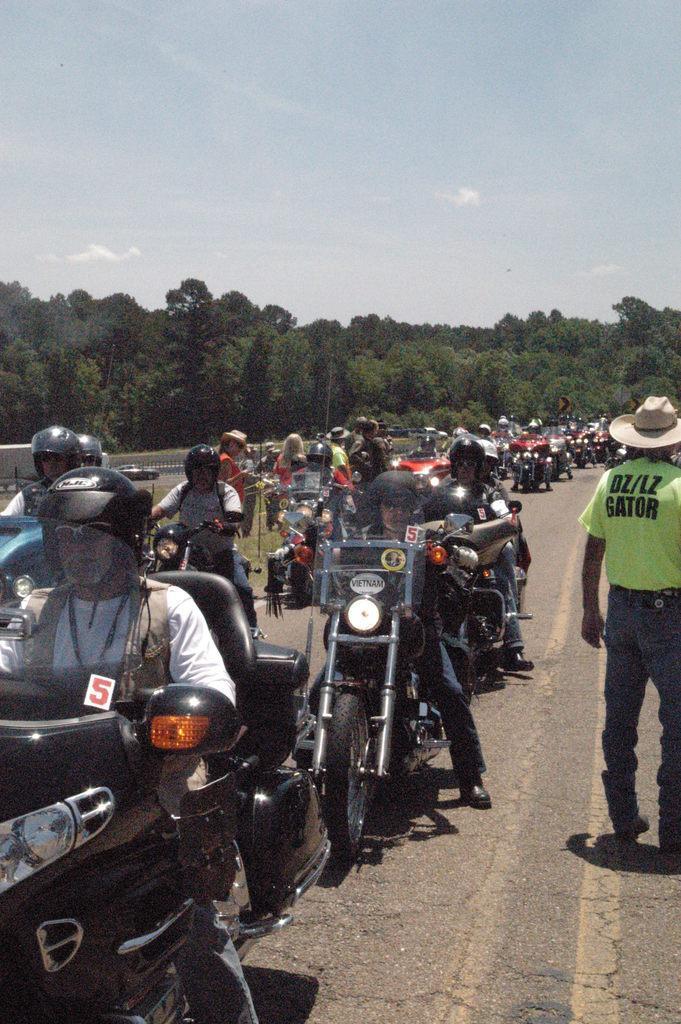Describe this image in one or two sentences. In this image there are many people wearing helmets and riding their bikes. To the right there is a man standing and wearing a green colored T-shirt and hat. He is standing on the road. In the background there are many trees. 